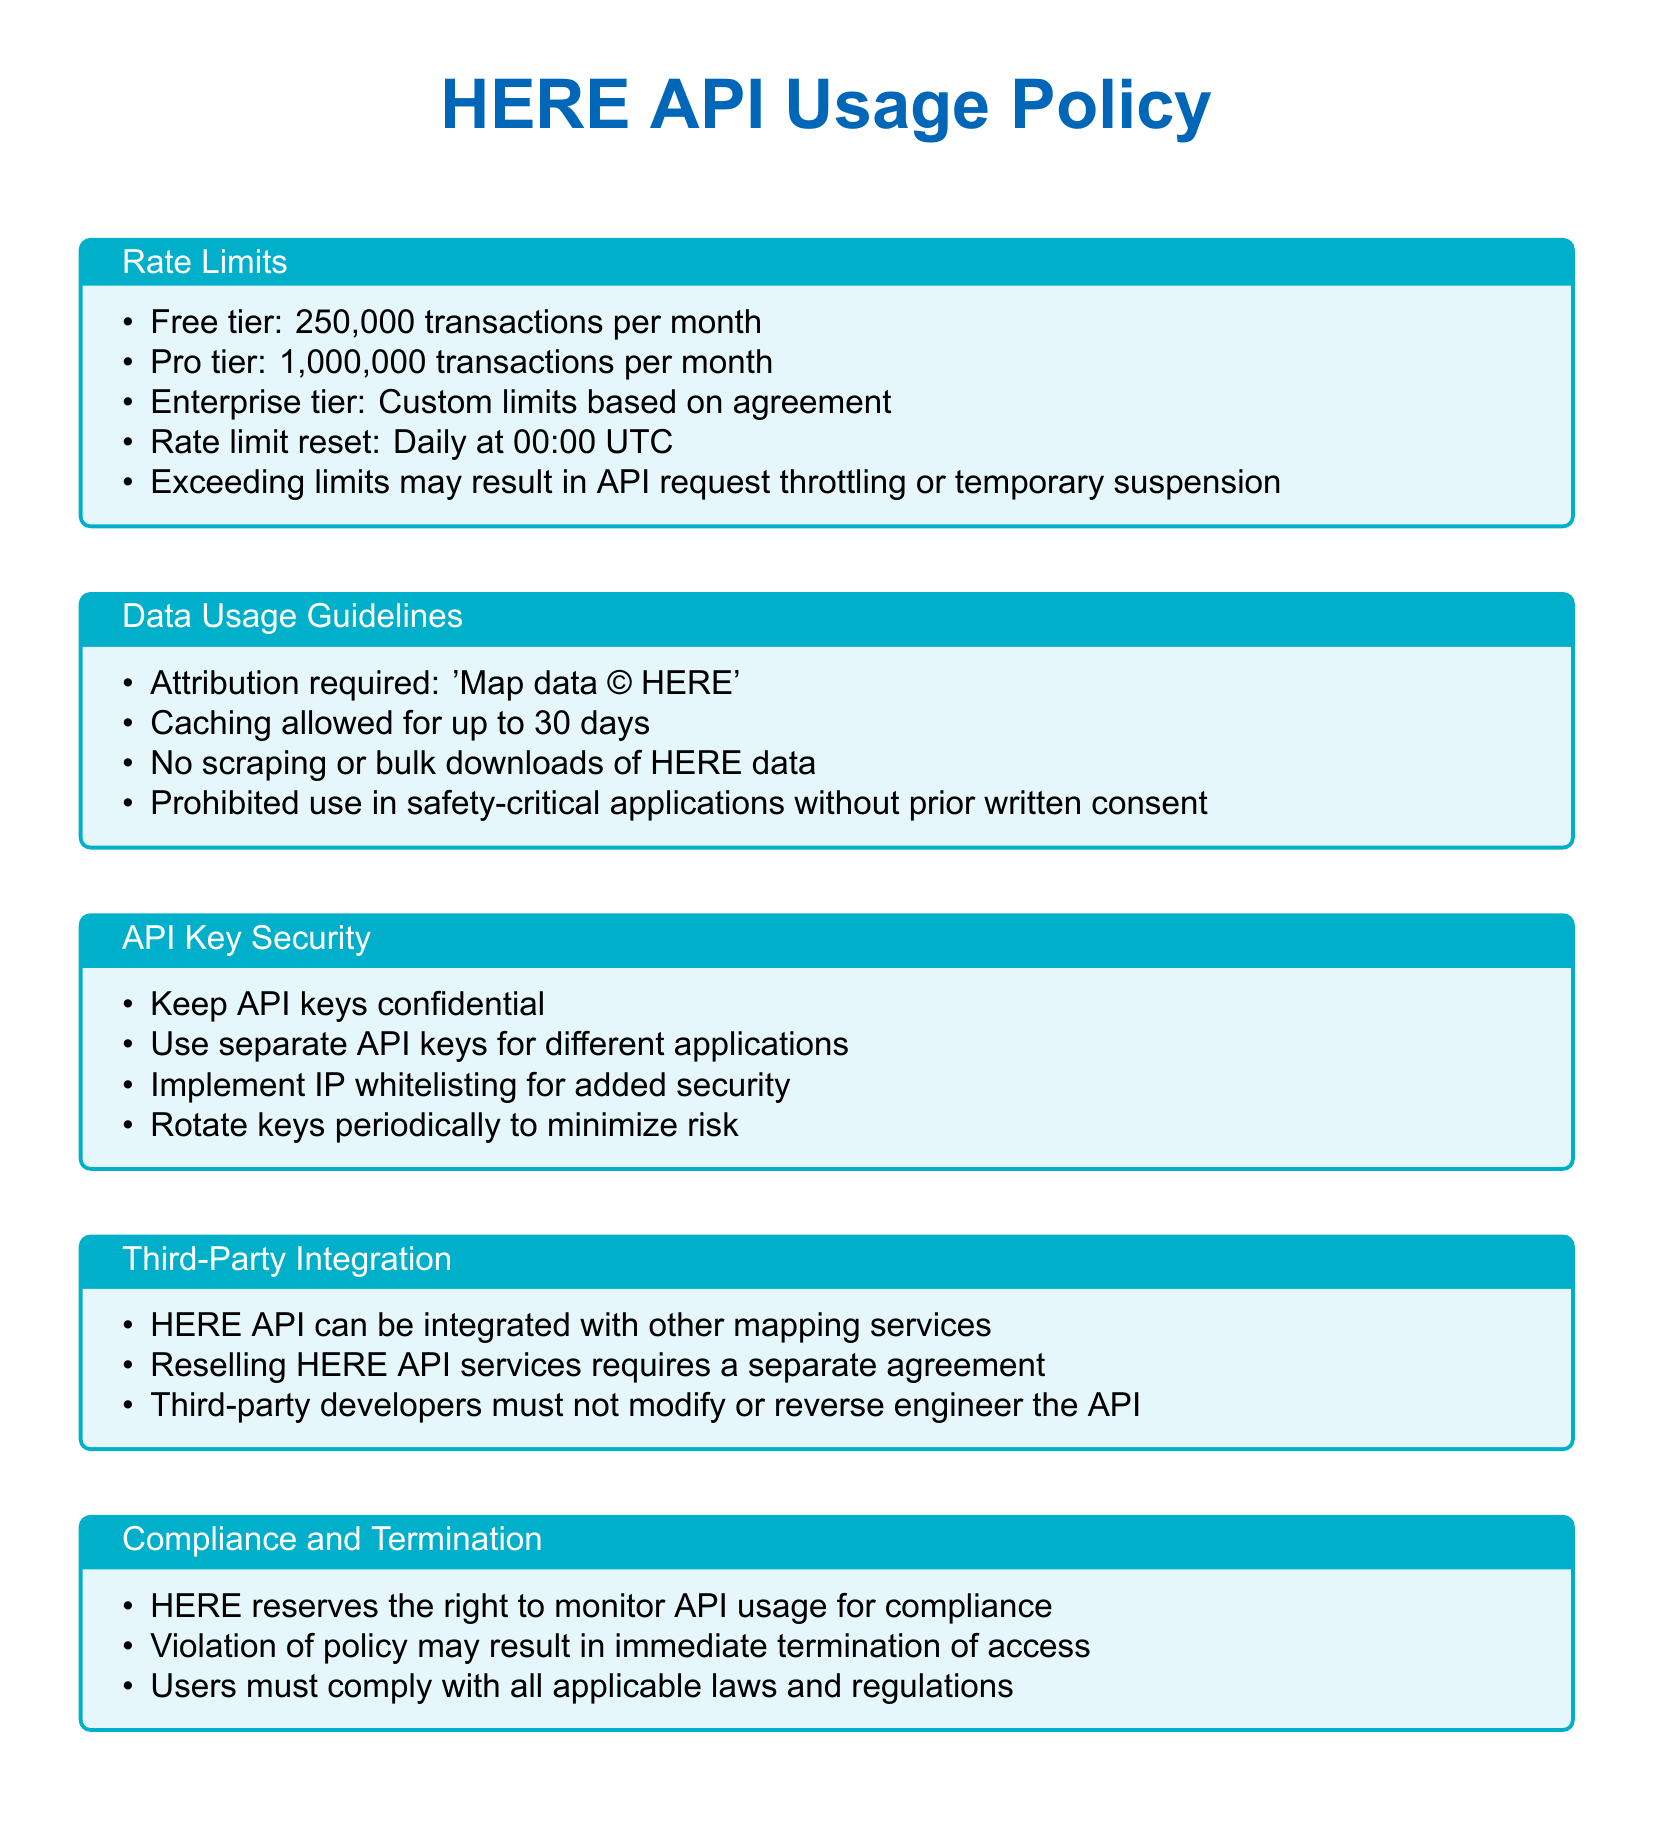What are the free tier transaction limits? The document specifies that the free tier has a limit of 250,000 transactions per month.
Answer: 250,000 transactions per month What is required for data attribution? According to the document, the attribution required is 'Map data © HERE'.
Answer: Map data © HERE How long is caching allowed? The document states that caching is allowed for up to 30 days.
Answer: 30 days What must third-party developers not do with the API? The document outlines that third-party developers must not modify or reverse engineer the API.
Answer: Modify or reverse engineer the API What action can HERE take for policy violations? The document mentions that violations of the policy may result in immediate termination of access.
Answer: Immediate termination of access How often do rate limits reset? The document indicates that rate limits reset daily at 00:00 UTC.
Answer: Daily at 00:00 UTC What additional security measure is suggested for API keys? The document advises implementing IP whitelisting for added security.
Answer: IP whitelisting What is required to resell HERE API services? The document specifies that reselling HERE API services requires a separate agreement.
Answer: A separate agreement What does HERE reserve the right to monitor? The document states that HERE reserves the right to monitor API usage for compliance.
Answer: API usage for compliance 